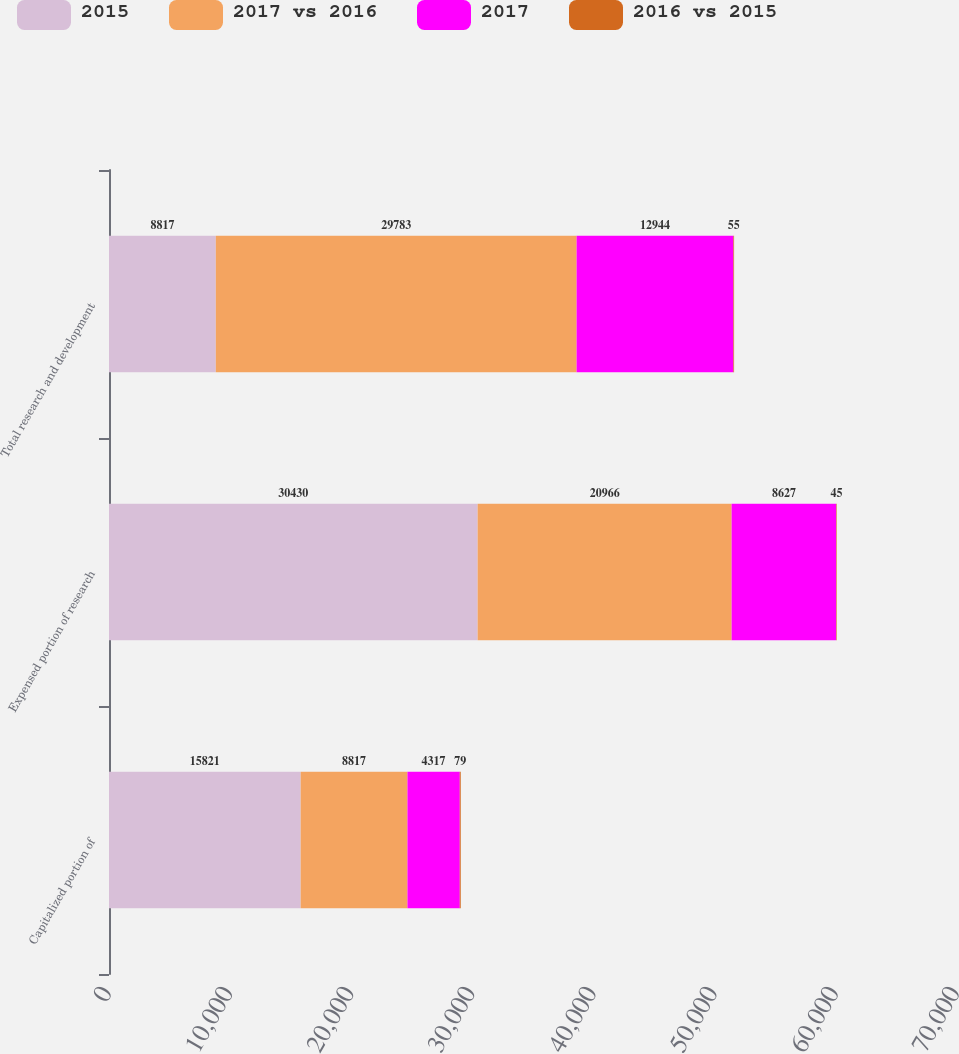Convert chart to OTSL. <chart><loc_0><loc_0><loc_500><loc_500><stacked_bar_chart><ecel><fcel>Capitalized portion of<fcel>Expensed portion of research<fcel>Total research and development<nl><fcel>2015<fcel>15821<fcel>30430<fcel>8817<nl><fcel>2017 vs 2016<fcel>8817<fcel>20966<fcel>29783<nl><fcel>2017<fcel>4317<fcel>8627<fcel>12944<nl><fcel>2016 vs 2015<fcel>79<fcel>45<fcel>55<nl></chart> 